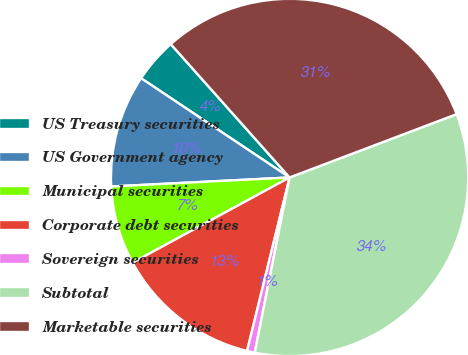Convert chart to OTSL. <chart><loc_0><loc_0><loc_500><loc_500><pie_chart><fcel>US Treasury securities<fcel>US Government agency<fcel>Municipal securities<fcel>Corporate debt securities<fcel>Sovereign securities<fcel>Subtotal<fcel>Marketable securities<nl><fcel>4.04%<fcel>10.18%<fcel>7.11%<fcel>13.26%<fcel>0.7%<fcel>33.89%<fcel>30.82%<nl></chart> 